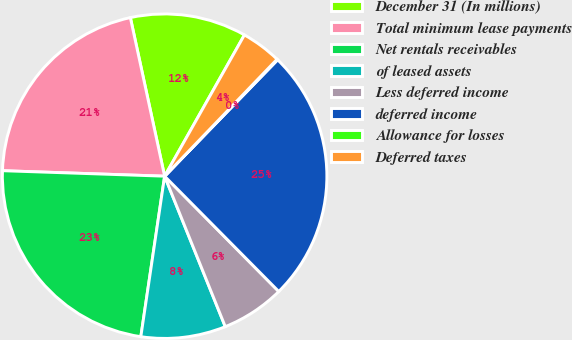Convert chart to OTSL. <chart><loc_0><loc_0><loc_500><loc_500><pie_chart><fcel>December 31 (In millions)<fcel>Total minimum lease payments<fcel>Net rentals receivables<fcel>of leased assets<fcel>Less deferred income<fcel>deferred income<fcel>Allowance for losses<fcel>Deferred taxes<nl><fcel>11.57%<fcel>21.07%<fcel>23.19%<fcel>8.44%<fcel>6.32%<fcel>25.31%<fcel>0.08%<fcel>4.0%<nl></chart> 